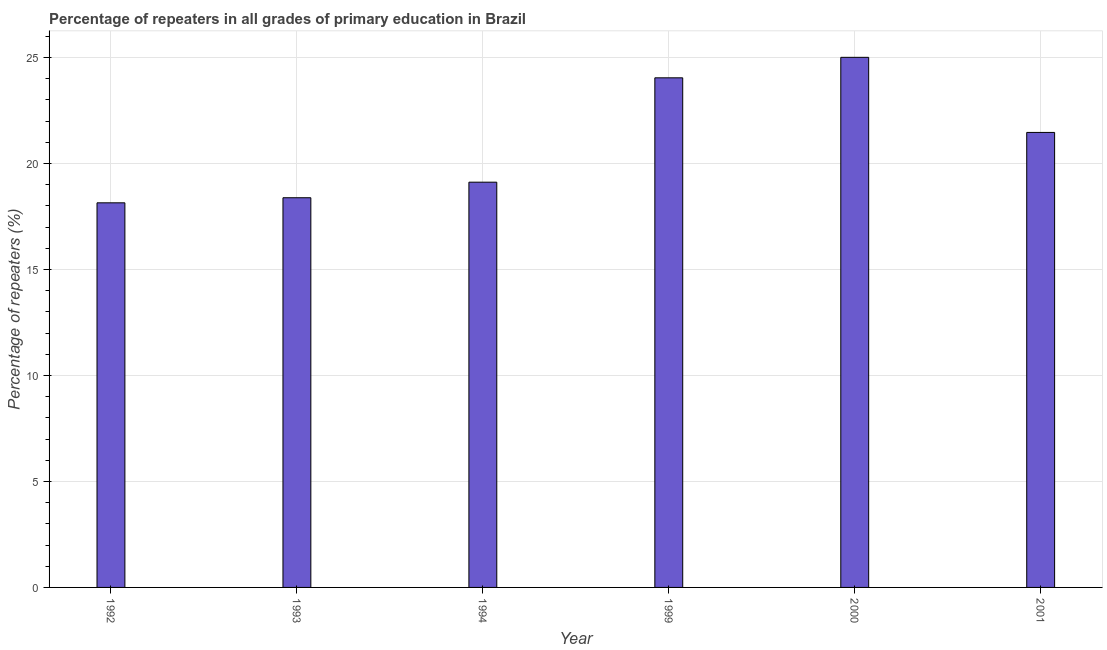Does the graph contain grids?
Make the answer very short. Yes. What is the title of the graph?
Keep it short and to the point. Percentage of repeaters in all grades of primary education in Brazil. What is the label or title of the X-axis?
Keep it short and to the point. Year. What is the label or title of the Y-axis?
Provide a succinct answer. Percentage of repeaters (%). What is the percentage of repeaters in primary education in 1992?
Offer a very short reply. 18.15. Across all years, what is the maximum percentage of repeaters in primary education?
Offer a terse response. 25.01. Across all years, what is the minimum percentage of repeaters in primary education?
Your response must be concise. 18.15. What is the sum of the percentage of repeaters in primary education?
Keep it short and to the point. 126.18. What is the difference between the percentage of repeaters in primary education in 1993 and 2000?
Provide a short and direct response. -6.62. What is the average percentage of repeaters in primary education per year?
Make the answer very short. 21.03. What is the median percentage of repeaters in primary education?
Provide a short and direct response. 20.29. What is the ratio of the percentage of repeaters in primary education in 1992 to that in 1999?
Offer a terse response. 0.76. What is the difference between the highest and the second highest percentage of repeaters in primary education?
Offer a very short reply. 0.97. What is the difference between the highest and the lowest percentage of repeaters in primary education?
Offer a very short reply. 6.86. In how many years, is the percentage of repeaters in primary education greater than the average percentage of repeaters in primary education taken over all years?
Offer a very short reply. 3. How many bars are there?
Ensure brevity in your answer.  6. What is the difference between two consecutive major ticks on the Y-axis?
Provide a short and direct response. 5. Are the values on the major ticks of Y-axis written in scientific E-notation?
Offer a terse response. No. What is the Percentage of repeaters (%) of 1992?
Provide a succinct answer. 18.15. What is the Percentage of repeaters (%) of 1993?
Offer a very short reply. 18.39. What is the Percentage of repeaters (%) in 1994?
Provide a succinct answer. 19.12. What is the Percentage of repeaters (%) in 1999?
Offer a very short reply. 24.04. What is the Percentage of repeaters (%) in 2000?
Keep it short and to the point. 25.01. What is the Percentage of repeaters (%) of 2001?
Your answer should be compact. 21.47. What is the difference between the Percentage of repeaters (%) in 1992 and 1993?
Provide a succinct answer. -0.24. What is the difference between the Percentage of repeaters (%) in 1992 and 1994?
Offer a terse response. -0.97. What is the difference between the Percentage of repeaters (%) in 1992 and 1999?
Offer a very short reply. -5.9. What is the difference between the Percentage of repeaters (%) in 1992 and 2000?
Ensure brevity in your answer.  -6.86. What is the difference between the Percentage of repeaters (%) in 1992 and 2001?
Ensure brevity in your answer.  -3.32. What is the difference between the Percentage of repeaters (%) in 1993 and 1994?
Ensure brevity in your answer.  -0.73. What is the difference between the Percentage of repeaters (%) in 1993 and 1999?
Offer a very short reply. -5.66. What is the difference between the Percentage of repeaters (%) in 1993 and 2000?
Make the answer very short. -6.63. What is the difference between the Percentage of repeaters (%) in 1993 and 2001?
Provide a short and direct response. -3.08. What is the difference between the Percentage of repeaters (%) in 1994 and 1999?
Your answer should be very brief. -4.92. What is the difference between the Percentage of repeaters (%) in 1994 and 2000?
Make the answer very short. -5.89. What is the difference between the Percentage of repeaters (%) in 1994 and 2001?
Offer a very short reply. -2.35. What is the difference between the Percentage of repeaters (%) in 1999 and 2000?
Your answer should be very brief. -0.97. What is the difference between the Percentage of repeaters (%) in 1999 and 2001?
Your answer should be compact. 2.58. What is the difference between the Percentage of repeaters (%) in 2000 and 2001?
Your answer should be very brief. 3.54. What is the ratio of the Percentage of repeaters (%) in 1992 to that in 1993?
Keep it short and to the point. 0.99. What is the ratio of the Percentage of repeaters (%) in 1992 to that in 1994?
Ensure brevity in your answer.  0.95. What is the ratio of the Percentage of repeaters (%) in 1992 to that in 1999?
Your response must be concise. 0.76. What is the ratio of the Percentage of repeaters (%) in 1992 to that in 2000?
Provide a succinct answer. 0.73. What is the ratio of the Percentage of repeaters (%) in 1992 to that in 2001?
Offer a terse response. 0.84. What is the ratio of the Percentage of repeaters (%) in 1993 to that in 1994?
Your answer should be very brief. 0.96. What is the ratio of the Percentage of repeaters (%) in 1993 to that in 1999?
Provide a succinct answer. 0.77. What is the ratio of the Percentage of repeaters (%) in 1993 to that in 2000?
Give a very brief answer. 0.73. What is the ratio of the Percentage of repeaters (%) in 1993 to that in 2001?
Ensure brevity in your answer.  0.86. What is the ratio of the Percentage of repeaters (%) in 1994 to that in 1999?
Make the answer very short. 0.8. What is the ratio of the Percentage of repeaters (%) in 1994 to that in 2000?
Offer a very short reply. 0.76. What is the ratio of the Percentage of repeaters (%) in 1994 to that in 2001?
Your response must be concise. 0.89. What is the ratio of the Percentage of repeaters (%) in 1999 to that in 2000?
Provide a succinct answer. 0.96. What is the ratio of the Percentage of repeaters (%) in 1999 to that in 2001?
Provide a short and direct response. 1.12. What is the ratio of the Percentage of repeaters (%) in 2000 to that in 2001?
Keep it short and to the point. 1.17. 